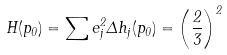<formula> <loc_0><loc_0><loc_500><loc_500>H ( p _ { 0 } ) = \sum e _ { j } ^ { 2 } \Delta h _ { j } ( p _ { 0 } ) = \left ( \frac { 2 } { 3 } \right ) ^ { 2 }</formula> 